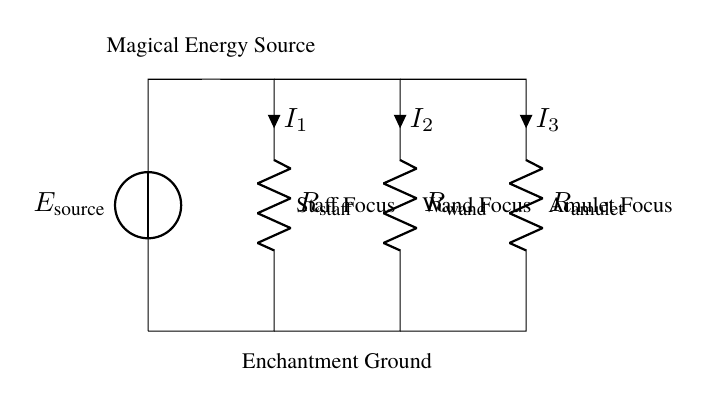What is the source of energy in this circuit? The circuit uses a magical energy source, indicated by the voltage source labeled as E_source. This provides the potential difference needed for the current to flow through the circuit.
Answer: magical energy source Which component has the highest current flowing through it? To determine the component with the highest current, we look at the individual currents indicated by I1, I2, and I3 across the resistors. Without the specific values of resistance, we cannot definitively say which one has the highest current; but generally, the current depends inversely on resistance. Assuming equal resistors, the staff may have the highest current due to its first position in the current divide.
Answer: staff focus How many spell focuses are there in the circuit? The circuit diagram shows three distinct components labeled as the staff focus, wand focus, and amulet focus, indicating that there are three separate spell focuses designed to utilize the energy.
Answer: three What is the total current supplied by the energy source? The total current can be found using Kirchhoff's current law, which states that the sum of currents entering a junction must equal the sum of currents leaving. Since we have three currents I1, I2, and I3, the total current (I_total) is the sum of these three currents: I_total = I1 + I2 + I3. Without specific values, we can't provide a numerical answer, but the relation is clear.
Answer: I1 + I2 + I3 Which focus would likely receive the least magical energy? The amulet focus is positioned furthest from the source; hence, it generally would experience the least current, assuming equal resistance. In a current divider, the lowest current usually flows through the highest resistance.
Answer: amulet focus 